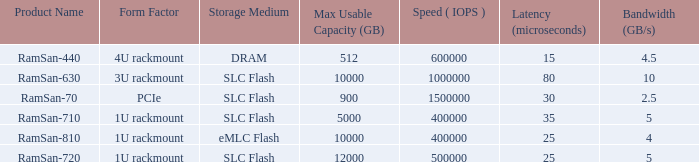What is the i/o actions per second for the emlc flash? 400000.0. 